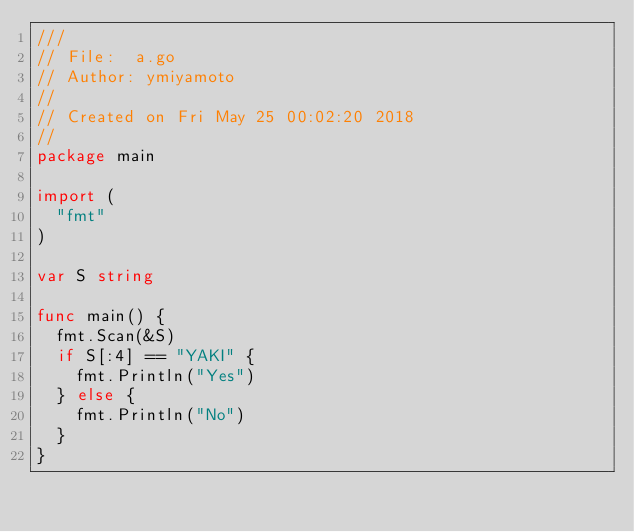<code> <loc_0><loc_0><loc_500><loc_500><_Go_>///
// File:  a.go
// Author: ymiyamoto
//
// Created on Fri May 25 00:02:20 2018
//
package main

import (
	"fmt"
)

var S string

func main() {
	fmt.Scan(&S)
	if S[:4] == "YAKI" {
		fmt.Println("Yes")
	} else {
		fmt.Println("No")
	}
}
</code> 